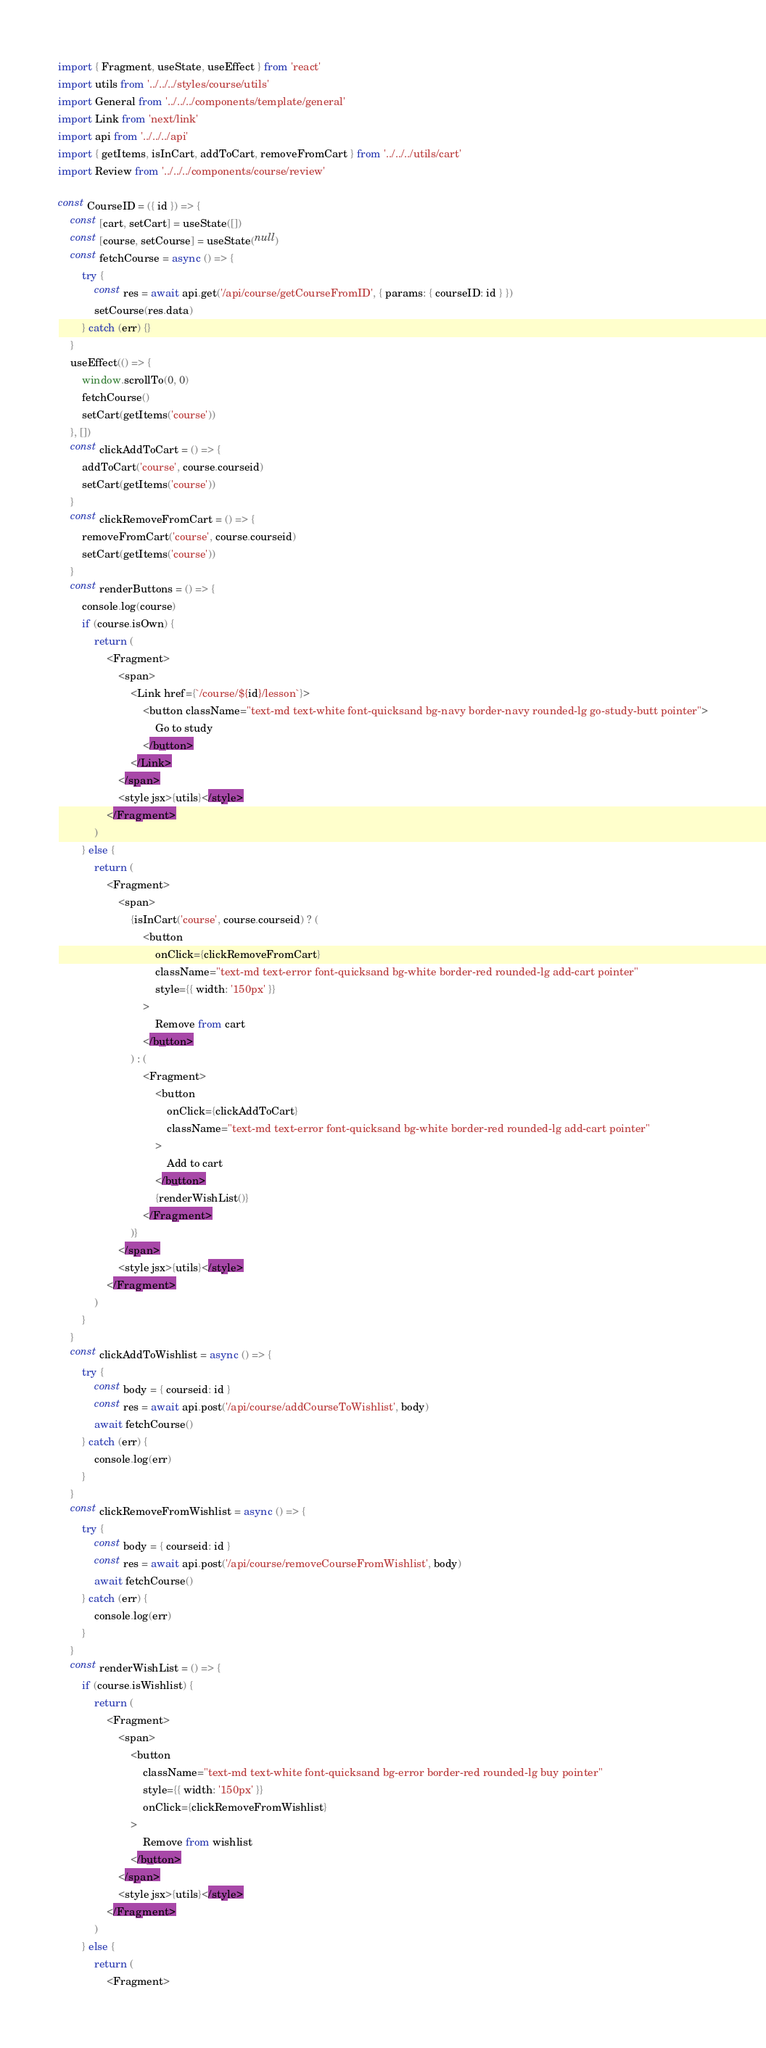<code> <loc_0><loc_0><loc_500><loc_500><_JavaScript_>import { Fragment, useState, useEffect } from 'react'
import utils from '../../../styles/course/utils'
import General from '../../../components/template/general'
import Link from 'next/link'
import api from '../../../api'
import { getItems, isInCart, addToCart, removeFromCart } from '../../../utils/cart'
import Review from '../../../components/course/review'

const CourseID = ({ id }) => {
	const [cart, setCart] = useState([])
	const [course, setCourse] = useState(null)
	const fetchCourse = async () => {
		try {
			const res = await api.get('/api/course/getCourseFromID', { params: { courseID: id } })
			setCourse(res.data)
		} catch (err) {}
	}
	useEffect(() => {
		window.scrollTo(0, 0)
		fetchCourse()
		setCart(getItems('course'))
	}, [])
	const clickAddToCart = () => {
		addToCart('course', course.courseid)
		setCart(getItems('course'))
	}
	const clickRemoveFromCart = () => {
		removeFromCart('course', course.courseid)
		setCart(getItems('course'))
	}
	const renderButtons = () => {
		console.log(course)
		if (course.isOwn) {
			return (
				<Fragment>
					<span>
						<Link href={`/course/${id}/lesson`}>
							<button className="text-md text-white font-quicksand bg-navy border-navy rounded-lg go-study-butt pointer">
								Go to study
							</button>
						</Link>
					</span>
					<style jsx>{utils}</style>
				</Fragment>
			)
		} else {
			return (
				<Fragment>
					<span>
						{isInCart('course', course.courseid) ? (
							<button
								onClick={clickRemoveFromCart}
								className="text-md text-error font-quicksand bg-white border-red rounded-lg add-cart pointer"
								style={{ width: '150px' }}
							>
								Remove from cart
							</button>
						) : (
							<Fragment>
								<button
									onClick={clickAddToCart}
									className="text-md text-error font-quicksand bg-white border-red rounded-lg add-cart pointer"
								>
									Add to cart
								</button>
								{renderWishList()}
							</Fragment>
						)}
					</span>
					<style jsx>{utils}</style>
				</Fragment>
			)
		}
	}
	const clickAddToWishlist = async () => {
		try {
			const body = { courseid: id }
			const res = await api.post('/api/course/addCourseToWishlist', body)
			await fetchCourse()
		} catch (err) {
			console.log(err)
		}
	}
	const clickRemoveFromWishlist = async () => {
		try {
			const body = { courseid: id }
			const res = await api.post('/api/course/removeCourseFromWishlist', body)
			await fetchCourse()
		} catch (err) {
			console.log(err)
		}
	}
	const renderWishList = () => {
		if (course.isWishlist) {
			return (
				<Fragment>
					<span>
						<button
							className="text-md text-white font-quicksand bg-error border-red rounded-lg buy pointer"
							style={{ width: '150px' }}
							onClick={clickRemoveFromWishlist}
						>
							Remove from wishlist
						</button>
					</span>
					<style jsx>{utils}</style>
				</Fragment>
			)
		} else {
			return (
				<Fragment></code> 